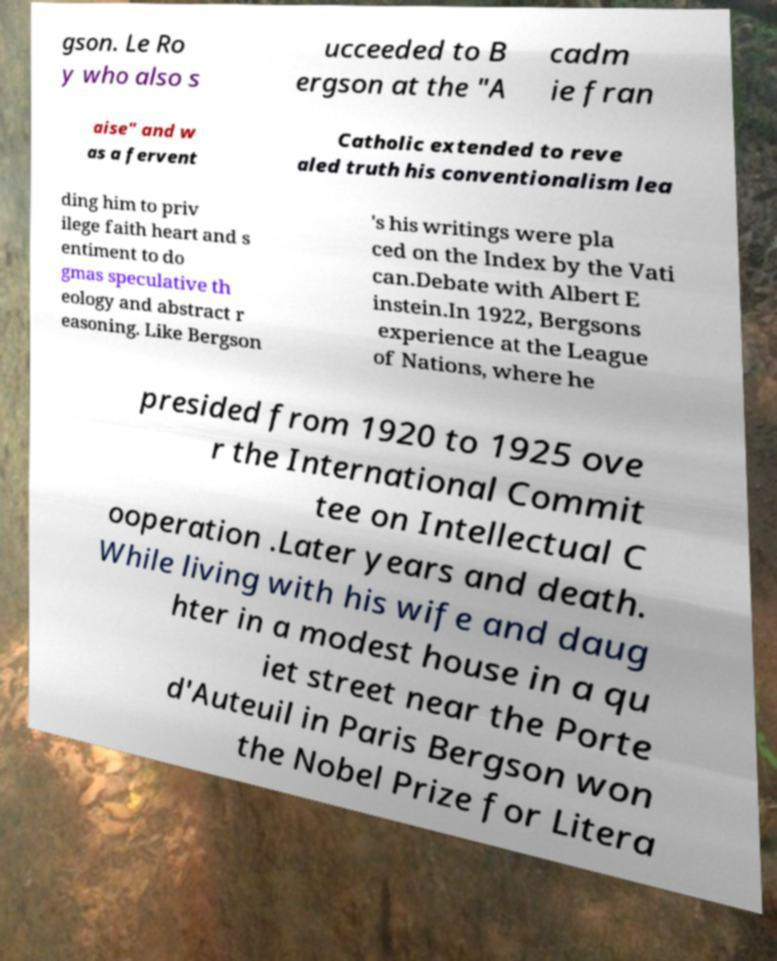Please identify and transcribe the text found in this image. gson. Le Ro y who also s ucceeded to B ergson at the "A cadm ie fran aise" and w as a fervent Catholic extended to reve aled truth his conventionalism lea ding him to priv ilege faith heart and s entiment to do gmas speculative th eology and abstract r easoning. Like Bergson 's his writings were pla ced on the Index by the Vati can.Debate with Albert E instein.In 1922, Bergsons experience at the League of Nations, where he presided from 1920 to 1925 ove r the International Commit tee on Intellectual C ooperation .Later years and death. While living with his wife and daug hter in a modest house in a qu iet street near the Porte d'Auteuil in Paris Bergson won the Nobel Prize for Litera 